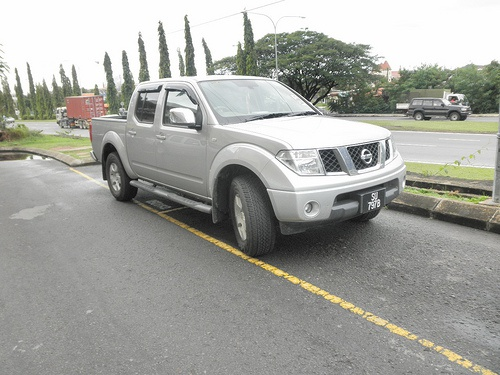Describe the objects in this image and their specific colors. I can see truck in white, lightgray, darkgray, gray, and black tones, truck in white, salmon, darkgray, and gray tones, truck in white, gray, darkgray, black, and lightgray tones, and truck in white, gray, darkgray, and lightgray tones in this image. 